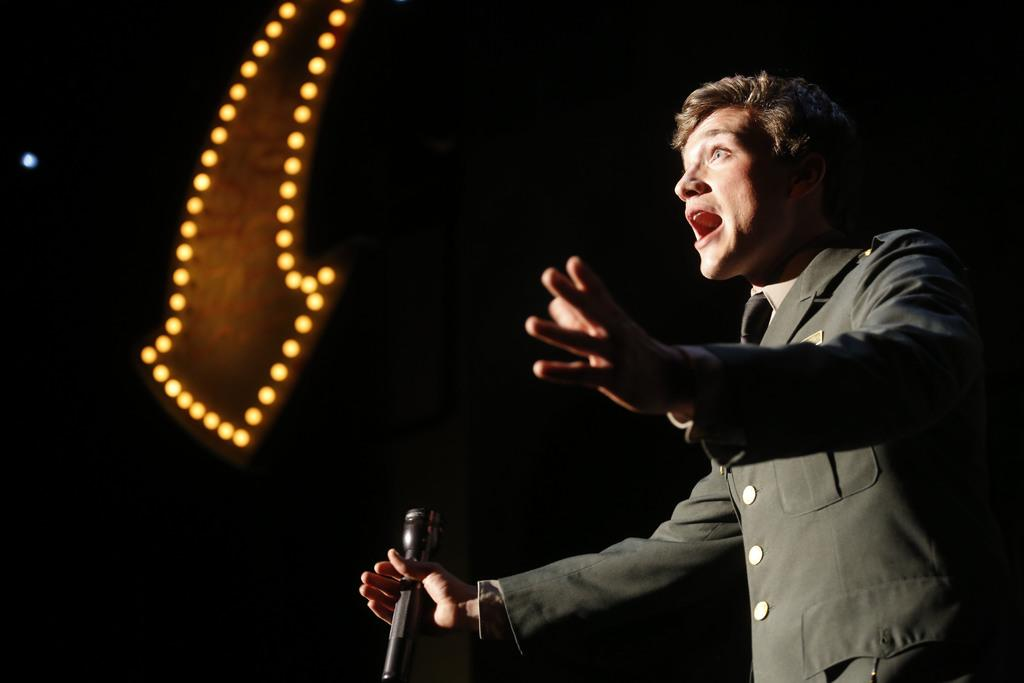What can be seen in the image? There is a person in the image. What is the person wearing? The person is wearing a black jacket. What is the person holding in his hand? The person is holding a mic in his hand. What can be seen on the left side of the image? There are lights on the left side of the image. How many beds are visible in the image? There are no beds visible in the image. 